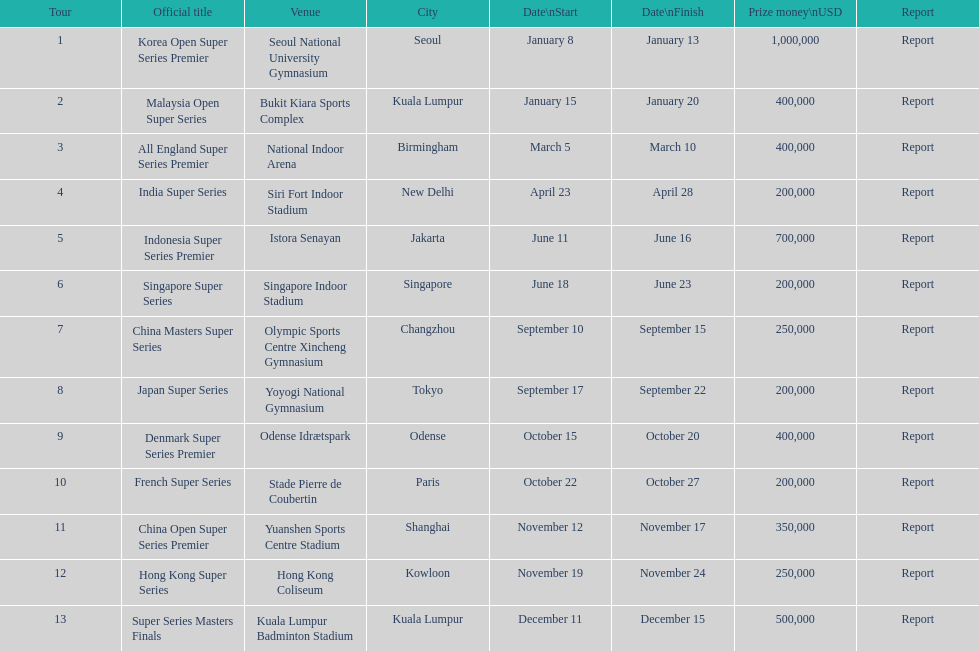What is the total prize payout for all 13 series? 5050000. Write the full table. {'header': ['Tour', 'Official title', 'Venue', 'City', 'Date\\nStart', 'Date\\nFinish', 'Prize money\\nUSD', 'Report'], 'rows': [['1', 'Korea Open Super Series Premier', 'Seoul National University Gymnasium', 'Seoul', 'January 8', 'January 13', '1,000,000', 'Report'], ['2', 'Malaysia Open Super Series', 'Bukit Kiara Sports Complex', 'Kuala Lumpur', 'January 15', 'January 20', '400,000', 'Report'], ['3', 'All England Super Series Premier', 'National Indoor Arena', 'Birmingham', 'March 5', 'March 10', '400,000', 'Report'], ['4', 'India Super Series', 'Siri Fort Indoor Stadium', 'New Delhi', 'April 23', 'April 28', '200,000', 'Report'], ['5', 'Indonesia Super Series Premier', 'Istora Senayan', 'Jakarta', 'June 11', 'June 16', '700,000', 'Report'], ['6', 'Singapore Super Series', 'Singapore Indoor Stadium', 'Singapore', 'June 18', 'June 23', '200,000', 'Report'], ['7', 'China Masters Super Series', 'Olympic Sports Centre Xincheng Gymnasium', 'Changzhou', 'September 10', 'September 15', '250,000', 'Report'], ['8', 'Japan Super Series', 'Yoyogi National Gymnasium', 'Tokyo', 'September 17', 'September 22', '200,000', 'Report'], ['9', 'Denmark Super Series Premier', 'Odense Idrætspark', 'Odense', 'October 15', 'October 20', '400,000', 'Report'], ['10', 'French Super Series', 'Stade Pierre de Coubertin', 'Paris', 'October 22', 'October 27', '200,000', 'Report'], ['11', 'China Open Super Series Premier', 'Yuanshen Sports Centre Stadium', 'Shanghai', 'November 12', 'November 17', '350,000', 'Report'], ['12', 'Hong Kong Super Series', 'Hong Kong Coliseum', 'Kowloon', 'November 19', 'November 24', '250,000', 'Report'], ['13', 'Super Series Masters Finals', 'Kuala Lumpur Badminton Stadium', 'Kuala Lumpur', 'December 11', 'December 15', '500,000', 'Report']]} 